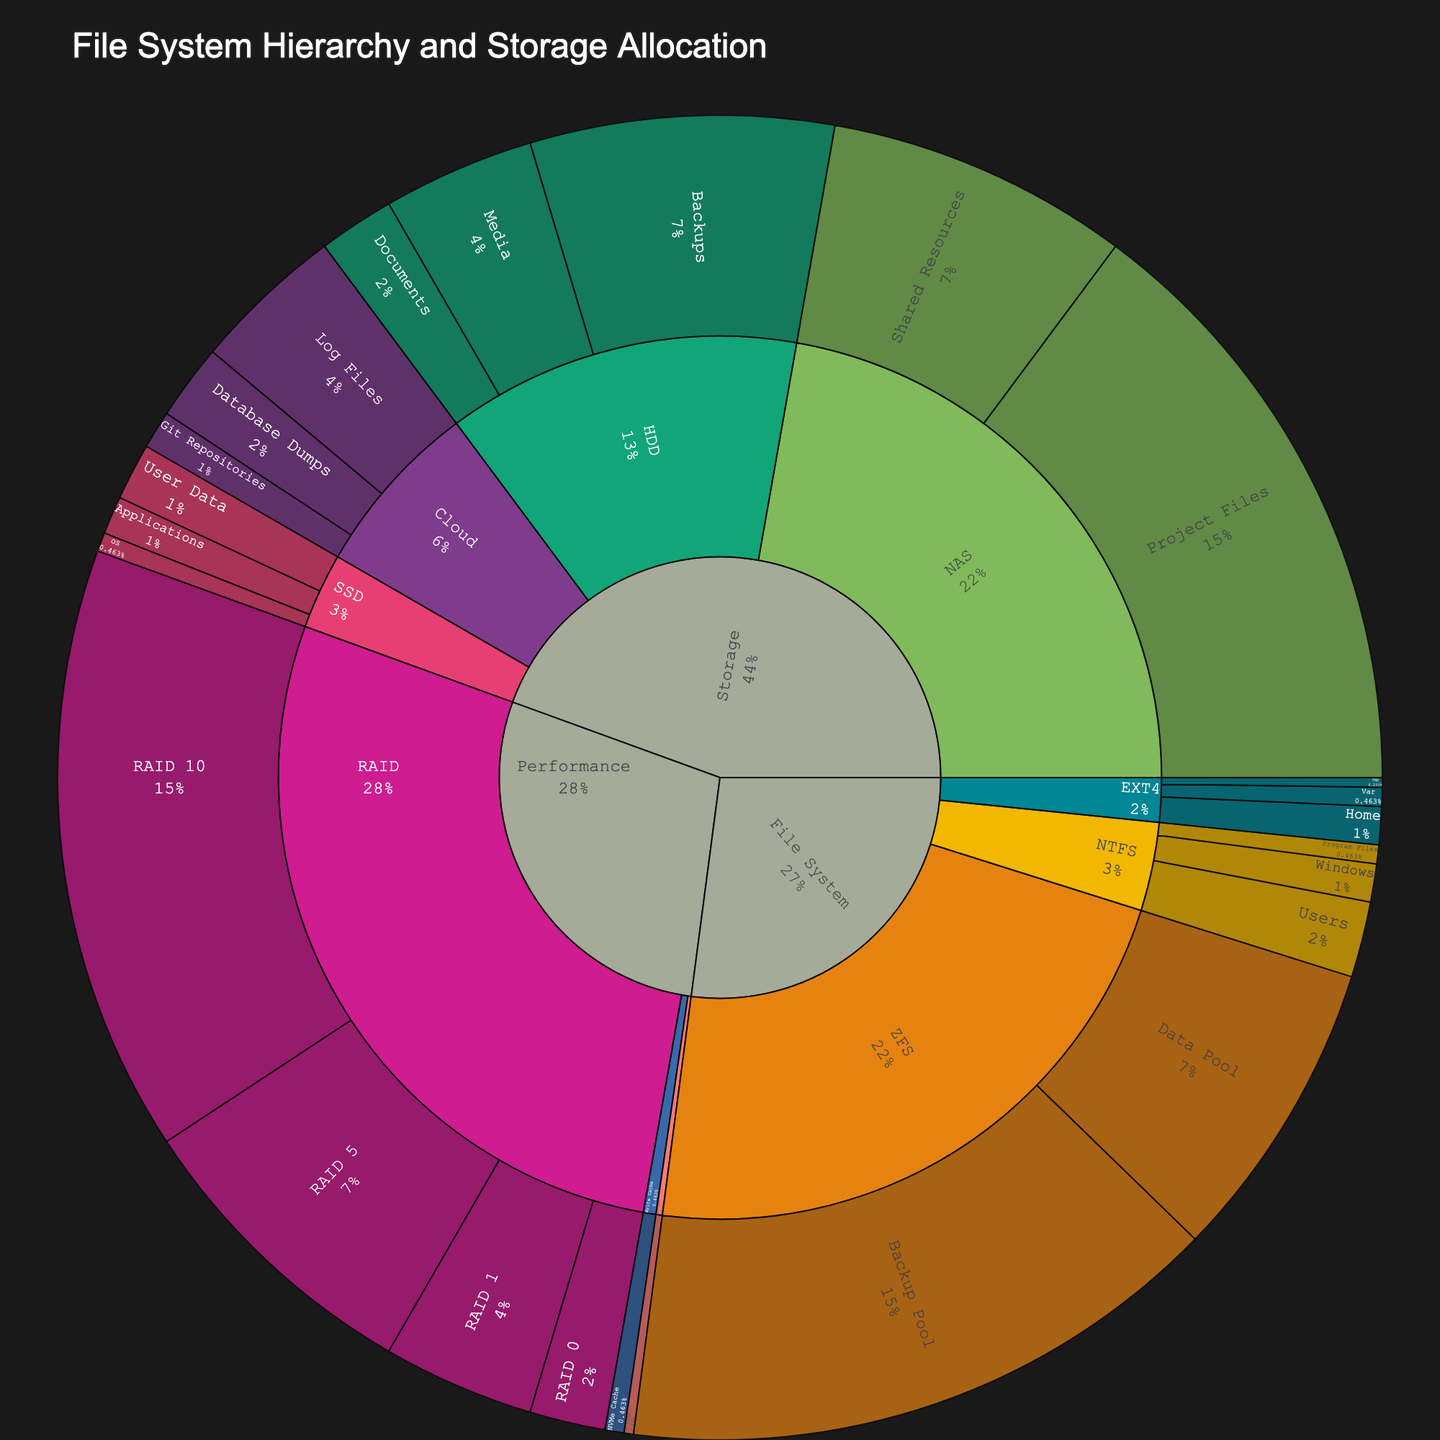What's the largest storage allocation category under "Storage"? Look at the "Storage" section of the plot and compare the sizes of "SSD", "HDD", "NAS", and "Cloud". "NAS" has the largest segments among them.
Answer: NAS Which specific subcategory has the largest size in the entire plot? Scan through all the subcategories for each category and compare their sizes. The "Backup Pool" under the "ZFS" file system has the largest size.
Answer: Backup Pool How much storage is allocated to different RAID configurations? Identify the "RAID" category under "Performance" and sum the sizes of "RAID 0", "RAID 1", "RAID 5", and "RAID 10". The sizes are: 1024, 2048, 4096, and 8192 respectively. Summing them gives 15360.
Answer: 15360 What percentage of the "Cloud" storage is allocated to "Log Files"? Find the "Cloud" category under "Storage" and look at the size of the "Log Files" subcategory. The size is 2048. Sum the sizes of all "Cloud" subcategories: 512 + 1024 + 2048 = 3584. Now, calculate the percentage: (2048 / 3584) * 100 = ~57.1%.
Answer: ~57.1% Compare the allocated storage of "HDD" and "SSD" under the "Storage" category. Which one is larger and by how much? Find the total sizes for "HDD" and "SSD" under "Storage" category. "HDD" has (1024 + 2048 + 4096) = 7168, and "SSD" has (256 + 512 + 768) = 1536. Subtract the total SSD size from HDD size: 7168 - 1536 = 5632.
Answer: HDD by 5632 Which category has the smallest read cache size allocation? Look at the "Read Cache" under the "Performance" category. There's only one subcategory, "SSD Cache", with a size of 128. This is the smallest since it's the only one present.
Answer: Read Cache What is the combined size allocated to "File System" categories EXT4 and NTFS? Add up sizes for subcategories under EXT4 and NTFS. EXT4: 512 + 256 + 128 = 896, NTFS: 512 + 256 + 1024 = 1792. Sum these two totals: 896 + 1792 = 2688.
Answer: 2688 What's the difference in size between "Program Files" in NTFS and "Var" in EXT4? Find their sizes under NTFS and EXT4. "Program Files" in NTFS has a size of 256, and "Var" in EXT4 has 256. Subtract Var's size from Program Files': 256 - 256 = 0.
Answer: 0 How does the size allocation for "User Data" in SSD compare to "Documents" in HDD? Locate these subcategories in SSD and HDD. "User Data" in SSD has a size of 768, while "Documents" in HDD has 1024. 768 is less than 1024.
Answer: "User Data" is smaller than "Documents" What is the median size of the subcategories under the "Storage" category? List the sizes of all subcategories under "Storage": [256, 512, 768, 1024, 2048, 4096, 8192, 4096, 512, 1024, 2048]. Sort these to [256, 512, 512, 768, 1024, 1024, 2048, 2048, 4096, 4096, 8192]. The median is the 6th value in the sorted list (1024).
Answer: 1024 